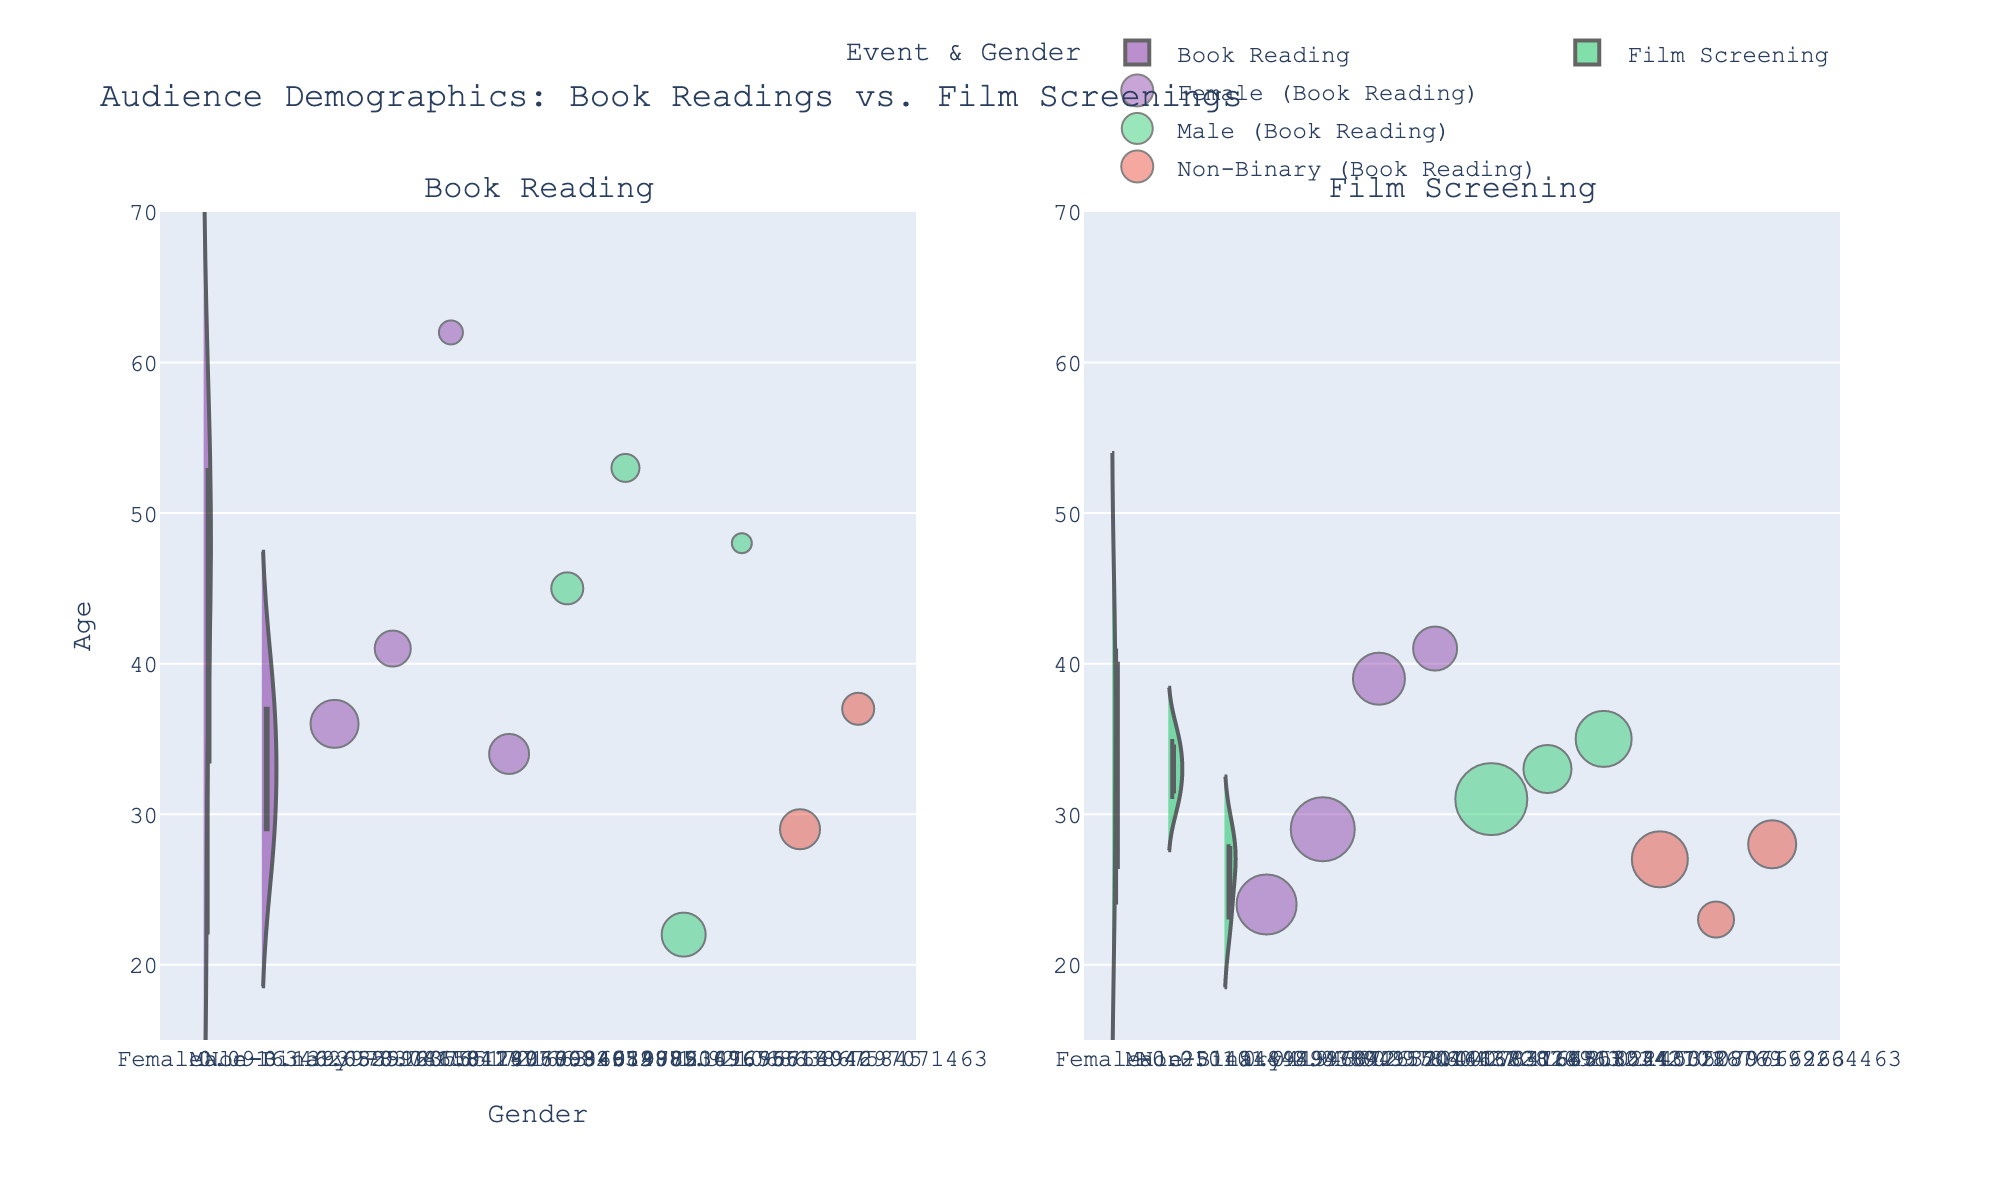What is the title of the figure? The title of the figure is displayed at the top center of the chart. It summarizes the content and purpose of the visualization.
Answer: "Audience Demographics: Book Readings vs. Film Screenings" What is the age range of the audience at book readings? The age range for book readings is represented on the y-axis for the "Book Reading" subplot. The minimum age is 22 and the maximum age is 62.
Answer: 22-62 How does the median age for females at film screenings compare to that for males? The median age is indicated by the meanline in the violin plot. For females, the median seems to be closer to 30, while for males, it is slightly below 35.
Answer: Females < Males Which gender group has the highest frequency points at film screenings? The size of the jittered points represents frequency. The largest points are among the females group, indicating that they have the highest frequency.
Answer: Females What is the average age for non-binary attendees at book readings? There are two ages for non-binary attendees at book readings: 29 and 37. Adding these together gives 66, and dividing by the 2 attendees gives an average of 33.
Answer: 33 Compare the age distributions of non-binary attendees between book readings and film screenings. The non-binary attendees at book readings range from 29-37, while for film screenings, the range is 23-28. The median age distribution at book readings is higher than film screenings.
Answer: Book Readings > Film Screenings Which event has a more spread-out distribution of ages? The spread of ages can be judged by the width and length of the violin plots. The 'Book Reading' event has ages spread from 22 to 62, while 'Film Screening' ranges from 23 to 41, making the distribution at book readings more spread out.
Answer: Book Reading How do the number of data points compare between the two events? Each jittered point represents an attendee; Book Reading has 10 points and Film Screening also has 10 points. Therefore, both events have the same number of data points.
Answer: Same number Among males, which event shows a wider variation in ages? For males, the violin plot for book readings spans from about 22 to 53, while film screenings span from 31 to 35. Thus, males at book readings show wider age variation.
Answer: Book Reading How do the frequency distributions differ between genders at film screenings? At film screenings, the frequency of points is indicated by their size. Female points are larger, indicating higher frequencies, while males have moderately sized points and non-binary points are smaller.
Answer: Females > Males > Non-Binary 